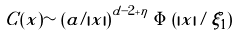<formula> <loc_0><loc_0><loc_500><loc_500>C ( x ) \sim \left ( \tilde { a } / | x | \right ) ^ { d - 2 + \eta } \, \Phi \left ( | x | / \xi _ { 1 } \right )</formula> 